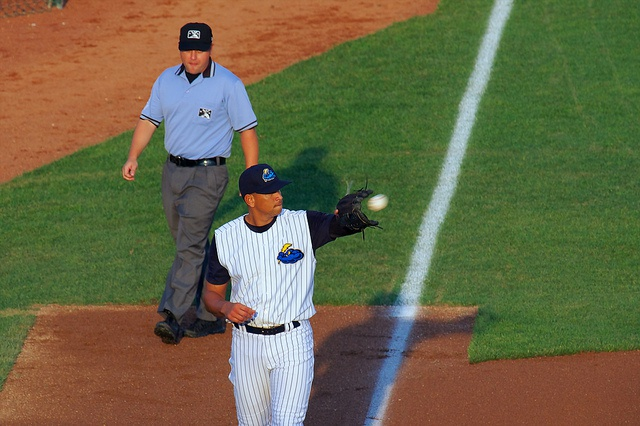Describe the objects in this image and their specific colors. I can see people in brown, lavender, black, and darkgray tones, people in brown, darkgray, gray, black, and darkgreen tones, baseball glove in brown, black, gray, and darkgreen tones, and sports ball in brown, tan, lightgray, beige, and darkgray tones in this image. 